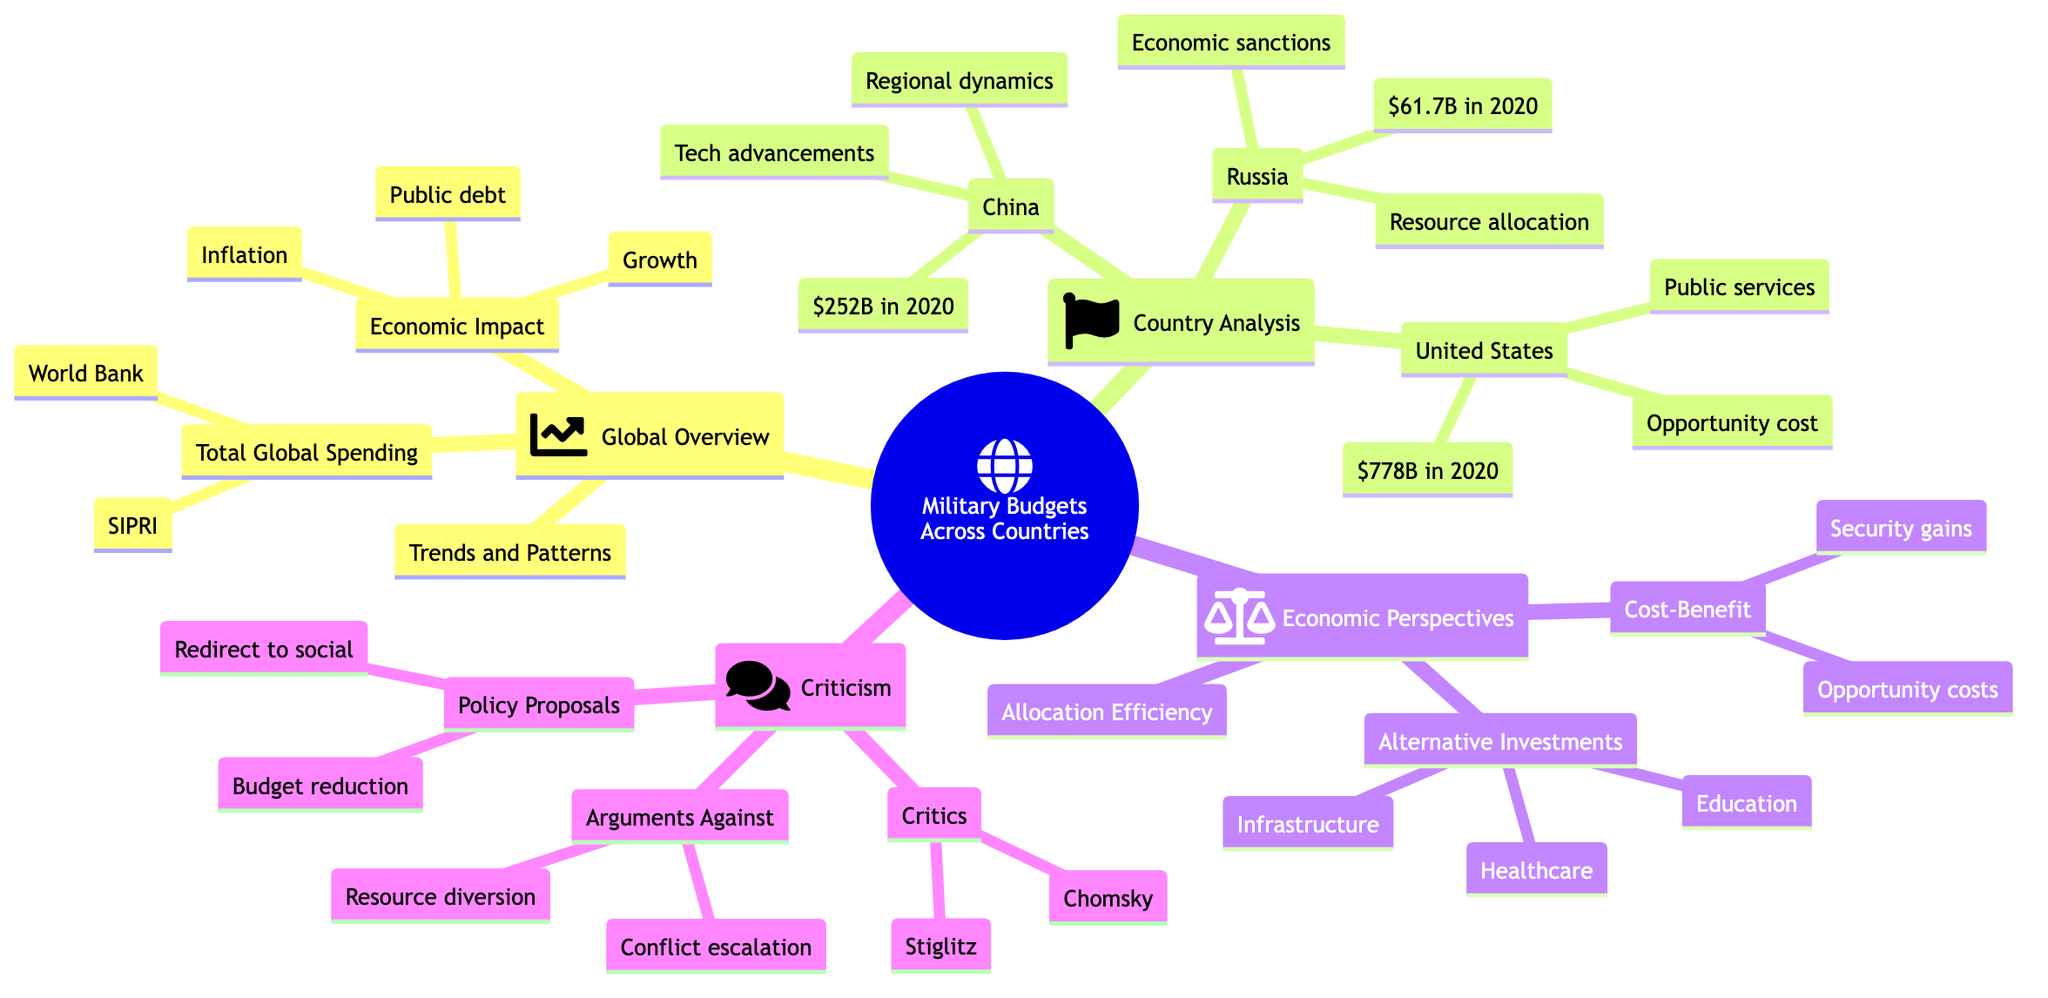What is the total military budget of the United States in 2020? The diagram specifies that the United States had a military budget of approximately 778 billion dollars in 2020, which is directly stated under the United States node in the Country-Specific Analysis section.
Answer: 778 billion Which two organizations are cited as data sources for global military spending? The diagram indicates that the Stockholm International Peace Research Institute (SIPRI) and the World Bank are the two organizations providing data sources under the Global Overview section.
Answer: SIPRI, World Bank What are the key areas impacted by military spending according to the Economic Impact section? The Economic Impact node specifies that military spending affects economic growth, public debt, and inflation, which are explicitly listed below this node.
Answer: Economic growth, public debt, inflation What was the military budget of China in 2020? The diagram provides recent figures for China’s military budget, stating it was approximately 252 billion dollars in 2020, directly noted in the Country-Specific Analysis subsection.
Answer: 252 billion Who are the notable figures that criticize military spending? The diagram lists Noam Chomsky and Joseph Stiglitz as notable critics under the Key Critics node in the Criticism and Reevaluation section.
Answer: Noam Chomsky, Joseph Stiglitz What is one argument against military spending mentioned in the diagram? The diagram presents several arguments against military spending, and one of them is that it promotes conflict escalation, which is included under the Arguments Against subsection.
Answer: Conflict escalation What type of analysis evaluates the returns of military spending relative to its costs? The Cost-Benefit Analysis subsection specifies that it evaluates the returns of military spending relative to its costs, which is stated clearly under the Economic Perspectives section.
Answer: Cost-Benefit Analysis What is the budget allocation for Russia in 2020? The military budget for Russia in 2020 is approximately 61.7 billion dollars, directly noted in the Country-Specific Analysis section under the Russia node.
Answer: 61.7 billion Which alternative investment areas are suggested instead of military spending? The diagram mentions education, healthcare, and infrastructure as alternative investment areas under the Alternative Investments subsection in the Economic Perspectives section.
Answer: Education, healthcare, infrastructure 